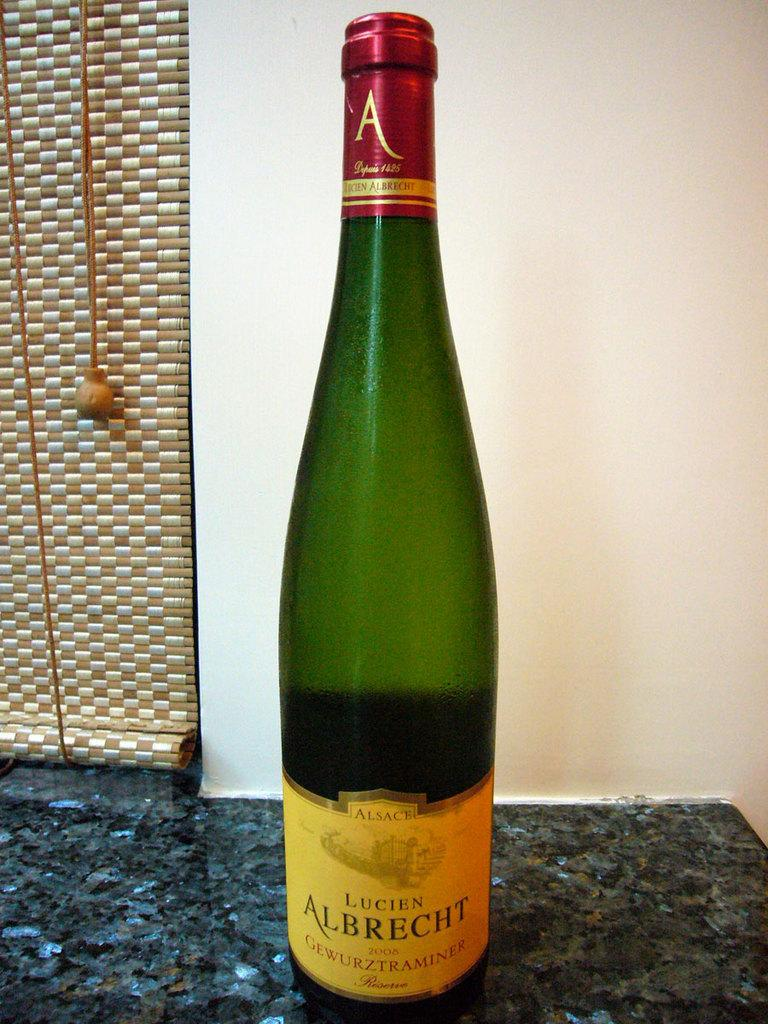<image>
Share a concise interpretation of the image provided. A bottle of  Lucien Albrecht 2208 on a granite counter top. 